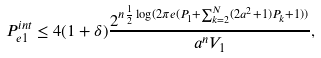Convert formula to latex. <formula><loc_0><loc_0><loc_500><loc_500>P _ { e 1 } ^ { i n t } \leq 4 ( 1 + \delta ) \frac { 2 ^ { n \frac { 1 } { 2 } \log ( 2 \pi e ( P _ { 1 } + \sum _ { k = 2 } ^ { N } ( 2 a ^ { 2 } + 1 ) P _ { k } + 1 ) ) } } { a ^ { n } V _ { 1 } } ,</formula> 